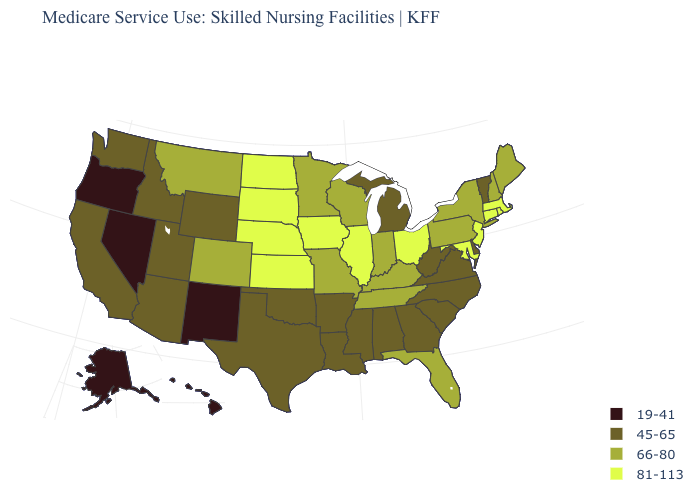What is the value of New York?
Give a very brief answer. 66-80. What is the value of Hawaii?
Give a very brief answer. 19-41. Name the states that have a value in the range 45-65?
Quick response, please. Alabama, Arizona, Arkansas, California, Delaware, Georgia, Idaho, Louisiana, Michigan, Mississippi, North Carolina, Oklahoma, South Carolina, Texas, Utah, Vermont, Virginia, Washington, West Virginia, Wyoming. Name the states that have a value in the range 19-41?
Quick response, please. Alaska, Hawaii, Nevada, New Mexico, Oregon. Does North Carolina have the same value as Idaho?
Keep it brief. Yes. Which states have the highest value in the USA?
Write a very short answer. Connecticut, Illinois, Iowa, Kansas, Maryland, Massachusetts, Nebraska, New Jersey, North Dakota, Ohio, Rhode Island, South Dakota. What is the lowest value in the USA?
Short answer required. 19-41. Which states have the highest value in the USA?
Answer briefly. Connecticut, Illinois, Iowa, Kansas, Maryland, Massachusetts, Nebraska, New Jersey, North Dakota, Ohio, Rhode Island, South Dakota. Name the states that have a value in the range 81-113?
Answer briefly. Connecticut, Illinois, Iowa, Kansas, Maryland, Massachusetts, Nebraska, New Jersey, North Dakota, Ohio, Rhode Island, South Dakota. Does California have the lowest value in the USA?
Be succinct. No. Which states have the highest value in the USA?
Short answer required. Connecticut, Illinois, Iowa, Kansas, Maryland, Massachusetts, Nebraska, New Jersey, North Dakota, Ohio, Rhode Island, South Dakota. Name the states that have a value in the range 45-65?
Be succinct. Alabama, Arizona, Arkansas, California, Delaware, Georgia, Idaho, Louisiana, Michigan, Mississippi, North Carolina, Oklahoma, South Carolina, Texas, Utah, Vermont, Virginia, Washington, West Virginia, Wyoming. Name the states that have a value in the range 19-41?
Answer briefly. Alaska, Hawaii, Nevada, New Mexico, Oregon. Name the states that have a value in the range 81-113?
Give a very brief answer. Connecticut, Illinois, Iowa, Kansas, Maryland, Massachusetts, Nebraska, New Jersey, North Dakota, Ohio, Rhode Island, South Dakota. 